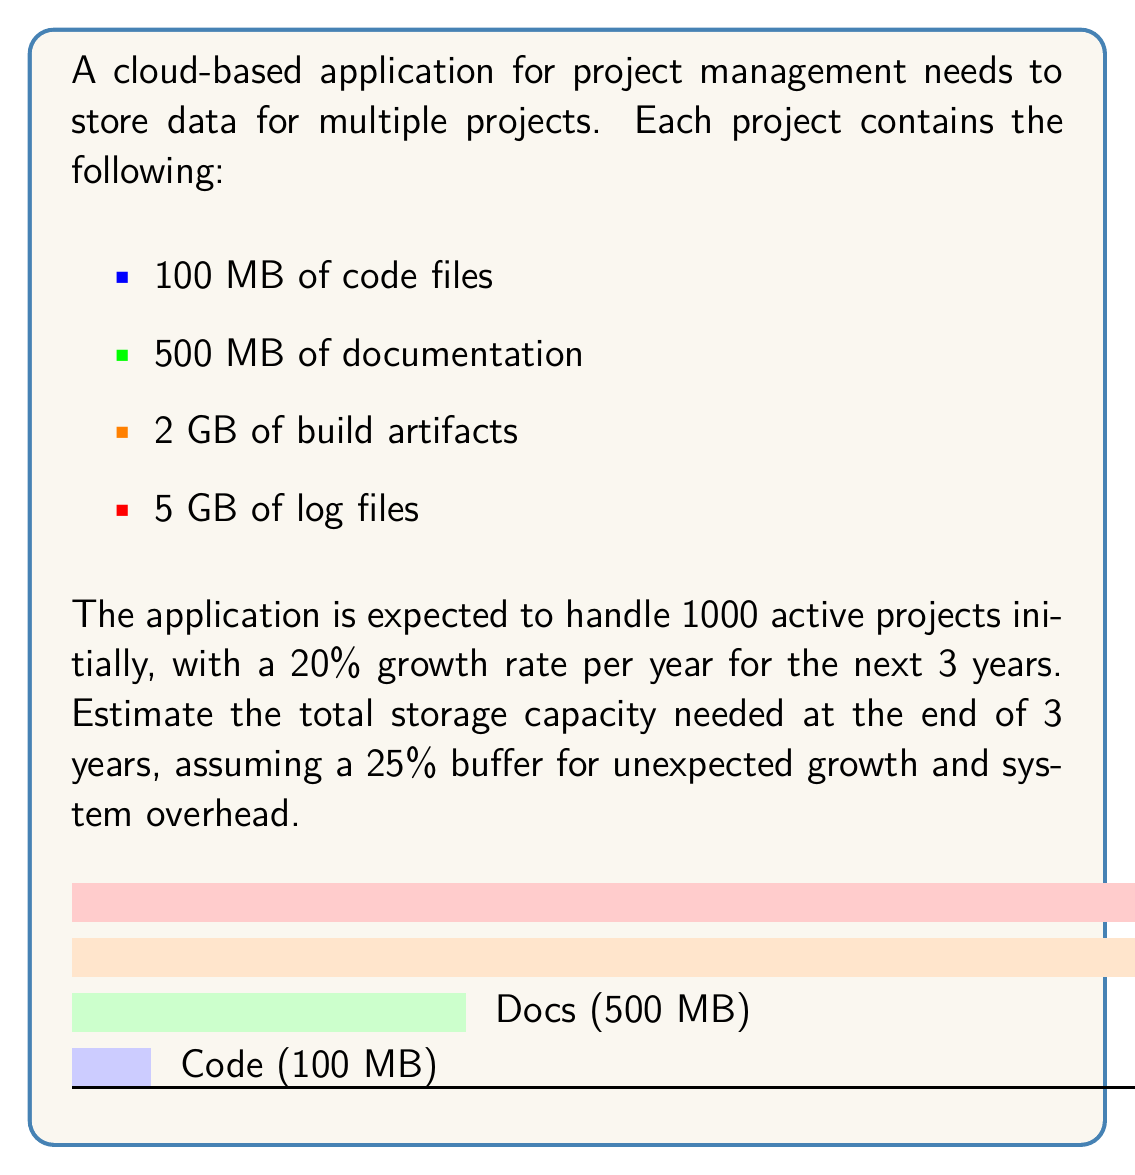What is the answer to this math problem? Let's break this down step-by-step:

1) First, calculate the total storage per project:
   $$100 \text{ MB} + 500 \text{ MB} + 2 \text{ GB} + 5 \text{ GB}$$
   $$= 0.1 \text{ GB} + 0.5 \text{ GB} + 2 \text{ GB} + 5 \text{ GB} = 7.6 \text{ GB}$$

2) Initial storage for 1000 projects:
   $$1000 \times 7.6 \text{ GB} = 7600 \text{ GB} = 7.6 \text{ TB}$$

3) Calculate the number of projects after 3 years with 20% annual growth:
   $$1000 \times (1 + 0.2)^3 = 1000 \times 1.728 = 1728 \text{ projects}$$

4) Storage needed for 1728 projects:
   $$1728 \times 7.6 \text{ GB} = 13132.8 \text{ GB} \approx 13.13 \text{ TB}$$

5) Add 25% buffer for unexpected growth and system overhead:
   $$13.13 \text{ TB} \times 1.25 = 16.4125 \text{ TB}$$

Therefore, the estimated storage capacity needed at the end of 3 years is approximately 16.41 TB.
Answer: 16.41 TB 